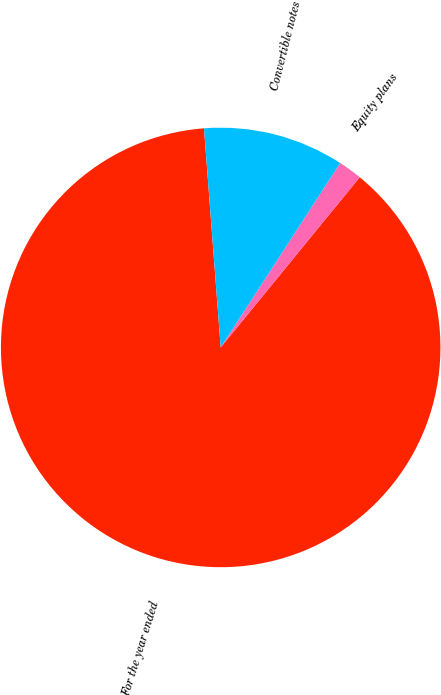Convert chart. <chart><loc_0><loc_0><loc_500><loc_500><pie_chart><fcel>For the year ended<fcel>Equity plans<fcel>Convertible notes<nl><fcel>87.89%<fcel>1.75%<fcel>10.36%<nl></chart> 